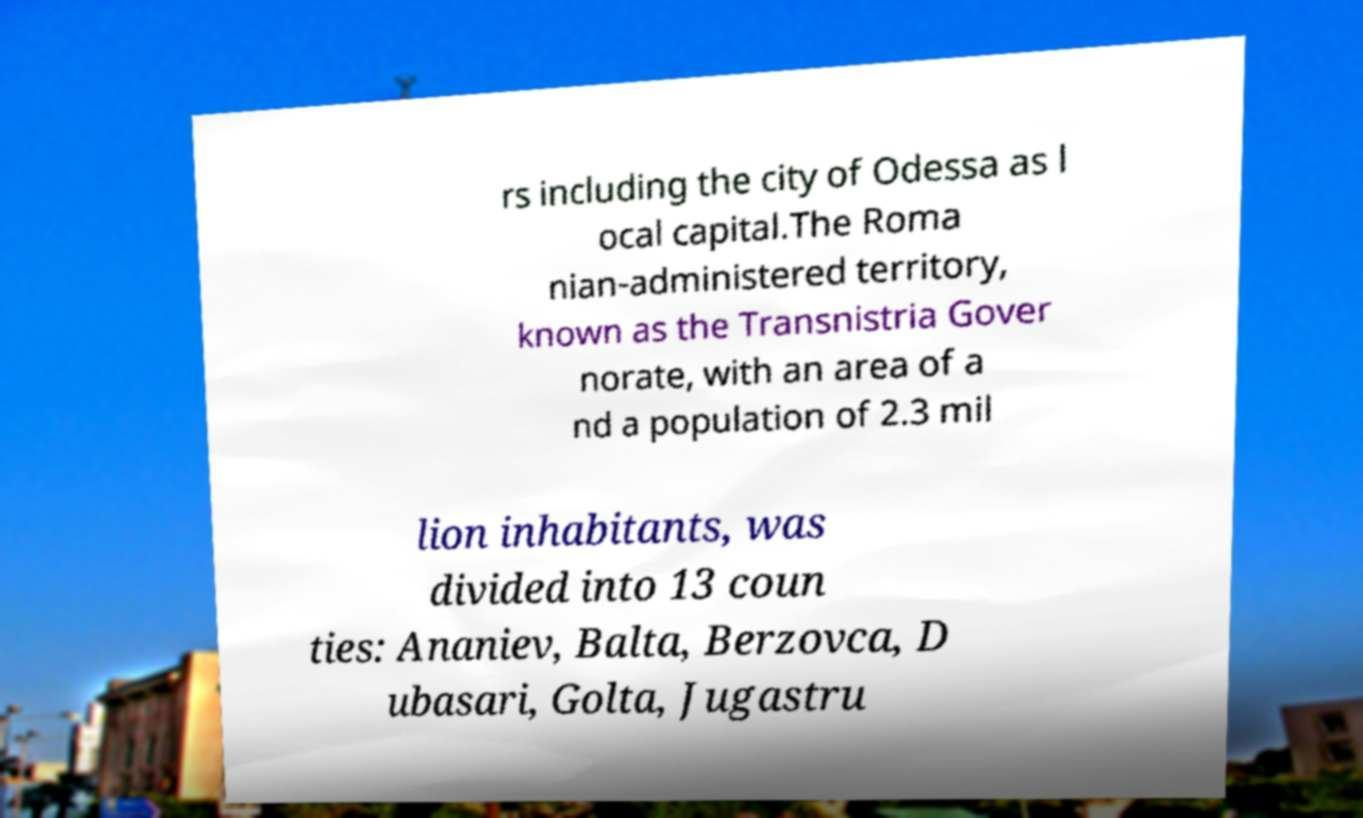Could you assist in decoding the text presented in this image and type it out clearly? rs including the city of Odessa as l ocal capital.The Roma nian-administered territory, known as the Transnistria Gover norate, with an area of a nd a population of 2.3 mil lion inhabitants, was divided into 13 coun ties: Ananiev, Balta, Berzovca, D ubasari, Golta, Jugastru 